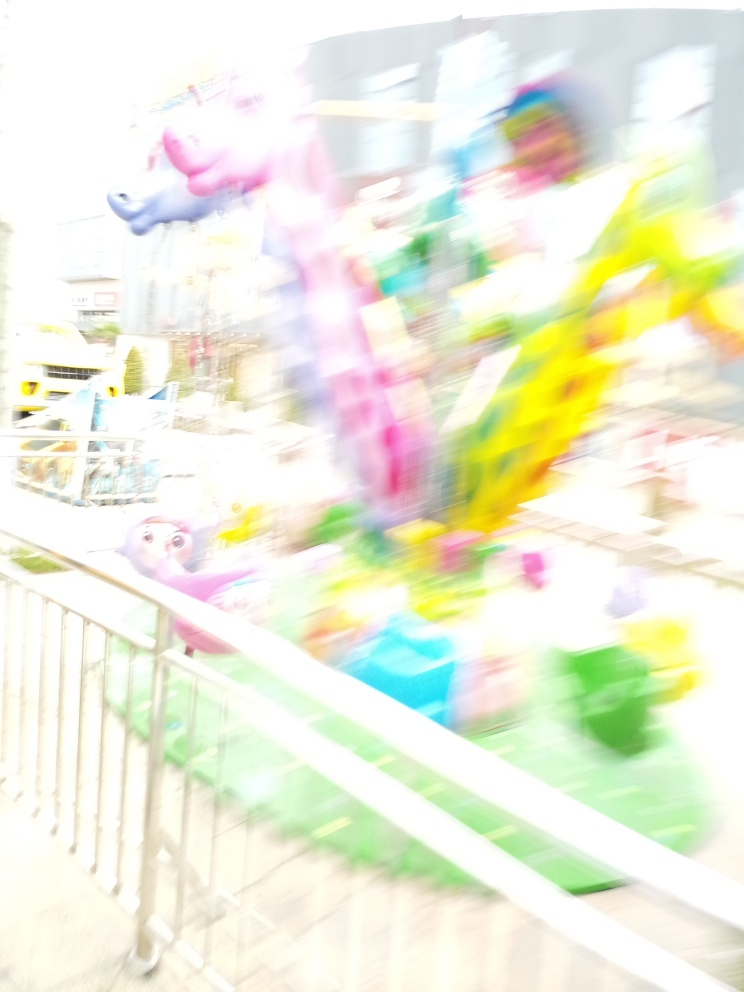Is the focusing of this image problematic? Yes, the image appears to be out of focus, with noticeable motion blur that diminishes the sharpness and clarity of the subjects within the frame. This can be a stylistic choice or a result of camera movement during a slow shutter speed exposure. 